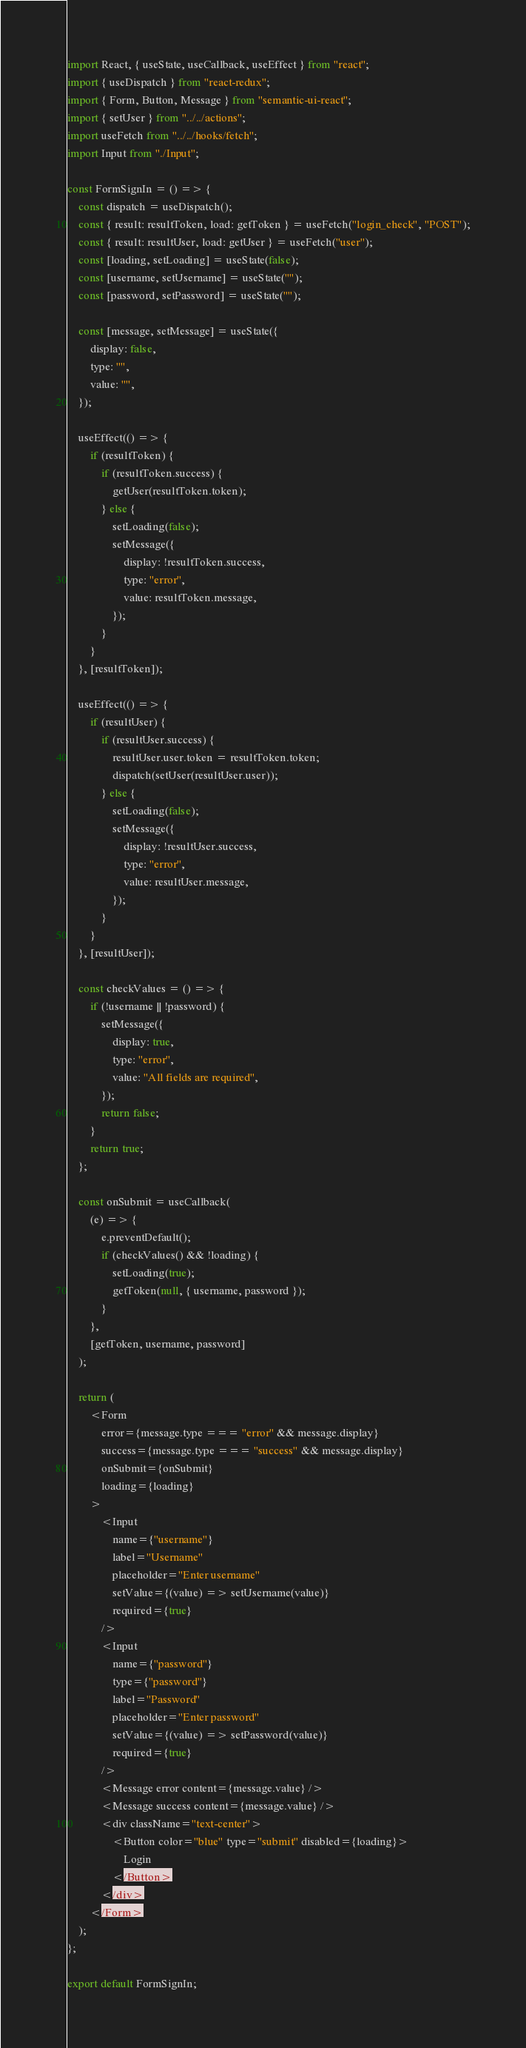Convert code to text. <code><loc_0><loc_0><loc_500><loc_500><_JavaScript_>import React, { useState, useCallback, useEffect } from "react";
import { useDispatch } from "react-redux";
import { Form, Button, Message } from "semantic-ui-react";
import { setUser } from "../../actions";
import useFetch from "../../hooks/fetch";
import Input from "./Input";

const FormSignIn = () => {
    const dispatch = useDispatch();
    const { result: resultToken, load: getToken } = useFetch("login_check", "POST");
    const { result: resultUser, load: getUser } = useFetch("user");
    const [loading, setLoading] = useState(false);
    const [username, setUsername] = useState("");
    const [password, setPassword] = useState("");

    const [message, setMessage] = useState({
        display: false,
        type: "",
        value: "",
    });

    useEffect(() => {
        if (resultToken) {
            if (resultToken.success) {
                getUser(resultToken.token);
            } else {
                setLoading(false);
                setMessage({
                    display: !resultToken.success,
                    type: "error",
                    value: resultToken.message,
                });
            }
        }
    }, [resultToken]);

    useEffect(() => {
        if (resultUser) {
            if (resultUser.success) {
                resultUser.user.token = resultToken.token;
                dispatch(setUser(resultUser.user));
            } else {
                setLoading(false);
                setMessage({
                    display: !resultUser.success,
                    type: "error",
                    value: resultUser.message,
                });
            }
        }
    }, [resultUser]);

    const checkValues = () => {
        if (!username || !password) {
            setMessage({
                display: true,
                type: "error",
                value: "All fields are required",
            });
            return false;
        }
        return true;
    };

    const onSubmit = useCallback(
        (e) => {
            e.preventDefault();
            if (checkValues() && !loading) {
                setLoading(true);
                getToken(null, { username, password });
            }
        },
        [getToken, username, password]
    );

    return (
        <Form
            error={message.type === "error" && message.display}
            success={message.type === "success" && message.display}
            onSubmit={onSubmit}
            loading={loading}
        >
            <Input
                name={"username"}
                label="Username"
                placeholder="Enter username"
                setValue={(value) => setUsername(value)}
                required={true}
            />
            <Input
                name={"password"}
                type={"password"}
                label="Password"
                placeholder="Enter password"
                setValue={(value) => setPassword(value)}
                required={true}
            />
            <Message error content={message.value} />
            <Message success content={message.value} />
            <div className="text-center">
                <Button color="blue" type="submit" disabled={loading}>
                    Login
                </Button>
            </div>
        </Form>
    );
};

export default FormSignIn;
</code> 